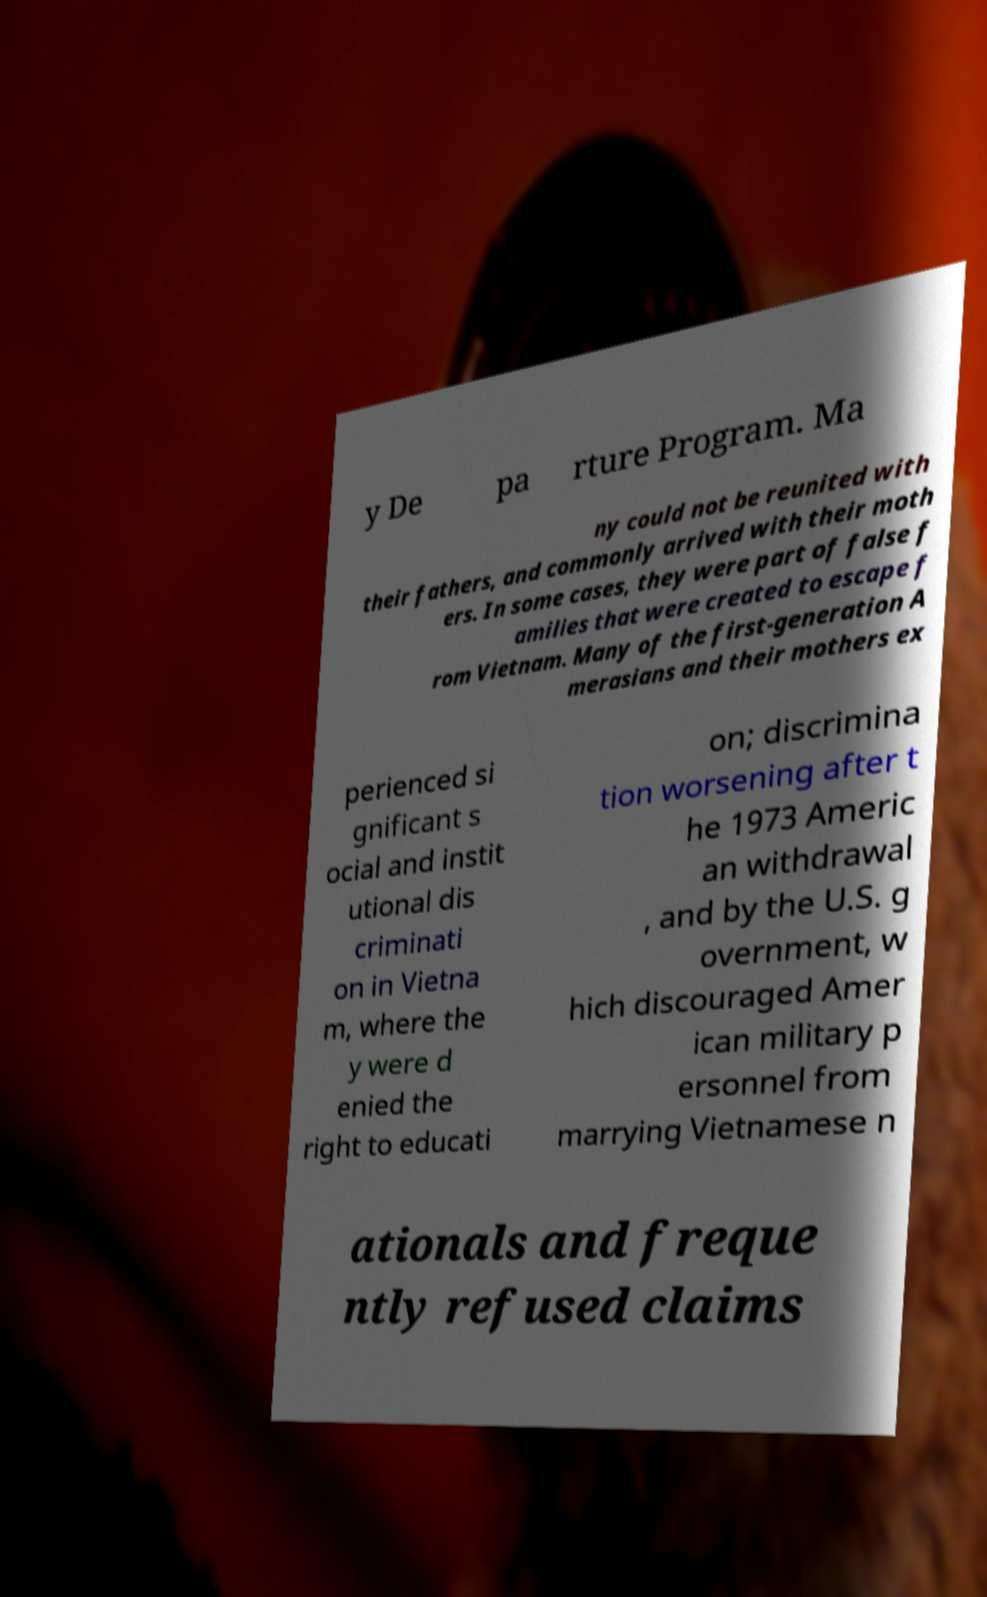Please identify and transcribe the text found in this image. y De pa rture Program. Ma ny could not be reunited with their fathers, and commonly arrived with their moth ers. In some cases, they were part of false f amilies that were created to escape f rom Vietnam. Many of the first-generation A merasians and their mothers ex perienced si gnificant s ocial and instit utional dis criminati on in Vietna m, where the y were d enied the right to educati on; discrimina tion worsening after t he 1973 Americ an withdrawal , and by the U.S. g overnment, w hich discouraged Amer ican military p ersonnel from marrying Vietnamese n ationals and freque ntly refused claims 